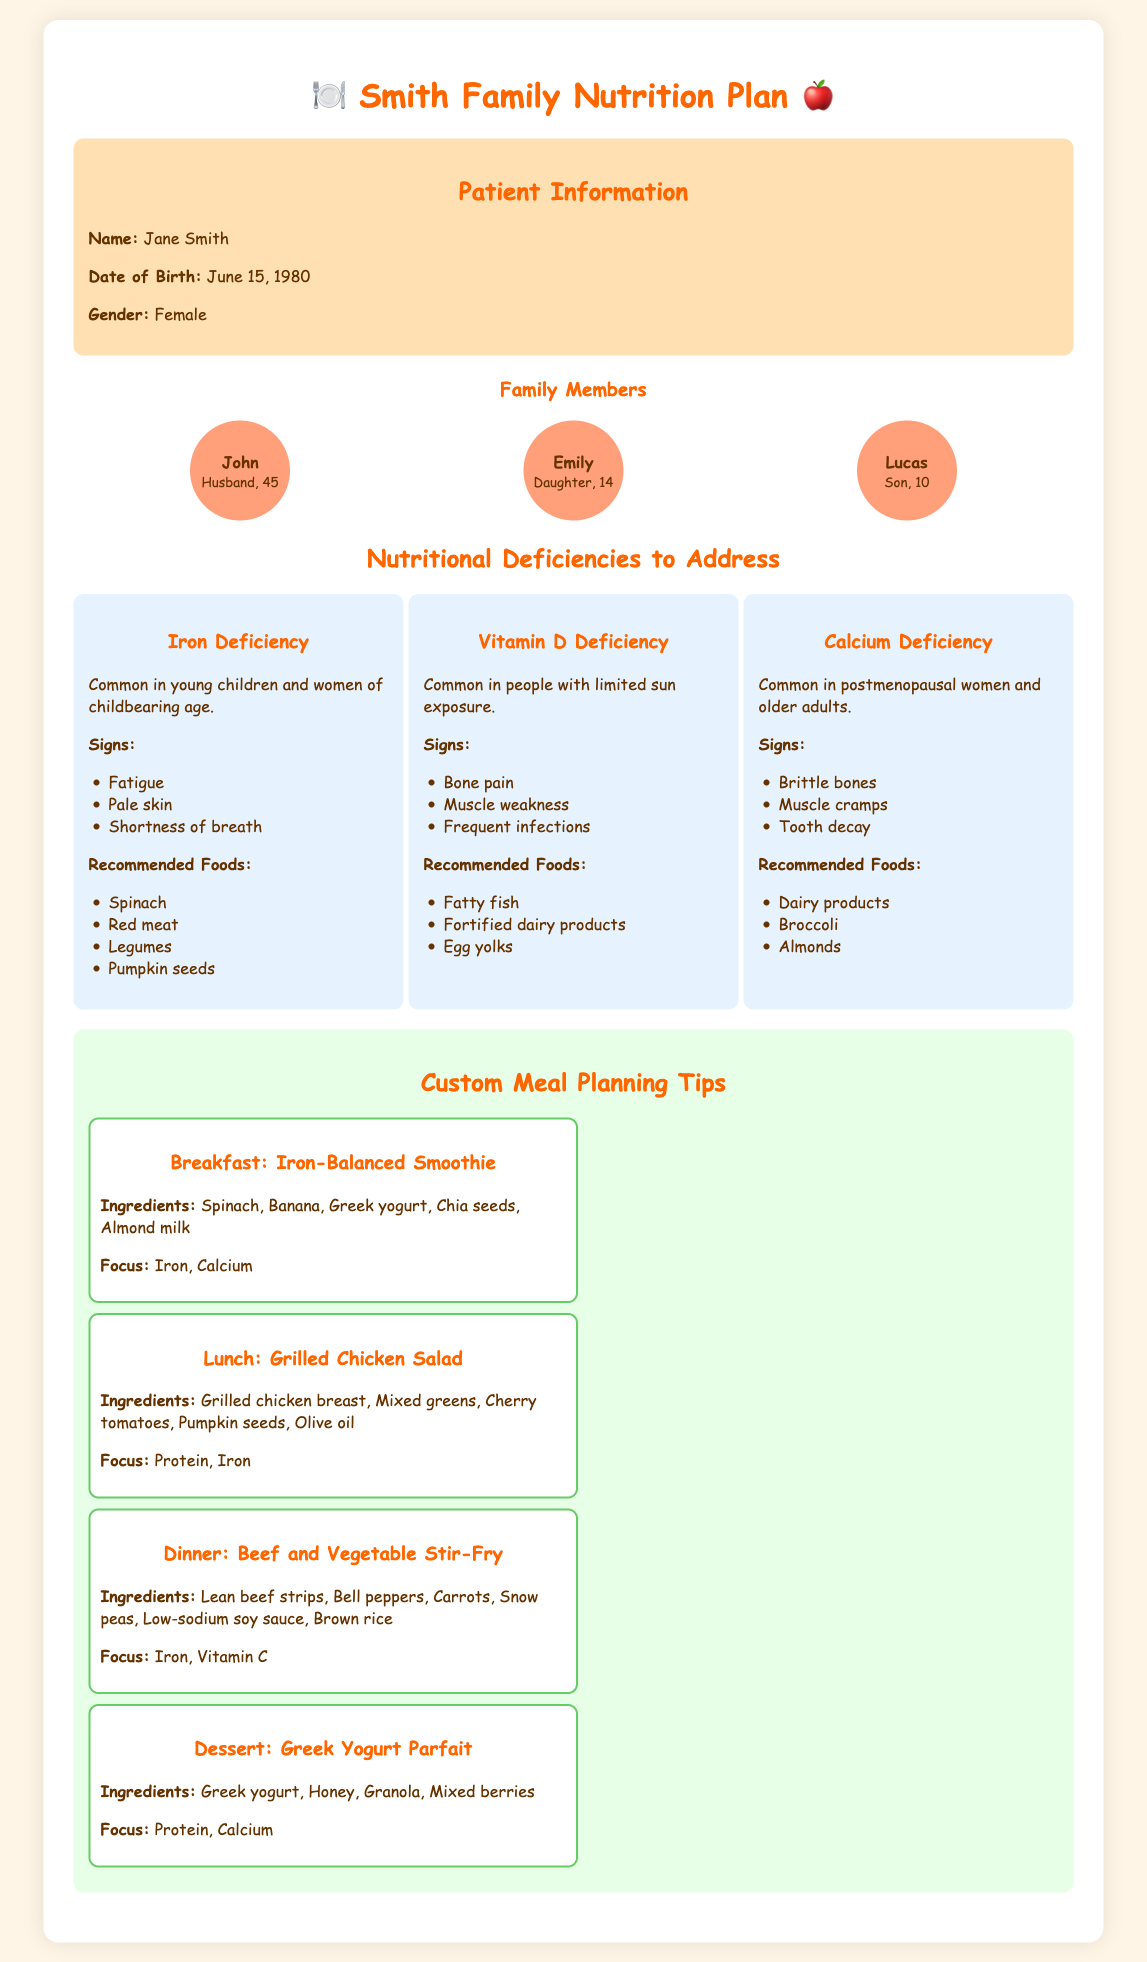What is the name of the patient? The name of the patient is stated in the patient information section of the document.
Answer: Jane Smith How many family members are listed? The document mentions the number of family members in the family members section.
Answer: 3 What is one sign of Iron Deficiency? The document lists signs of Iron Deficiency in a bullet list format.
Answer: Fatigue What is a recommended food for Vitamin D Deficiency? The document provides a list of recommended foods for Vitamin D Deficiency.
Answer: Fatty fish What is the age of Emily? Emily's age is mentioned in the family members section.
Answer: 14 Which meal focuses on Iron and Calcium? The document specifies the focus of each meal and the corresponding meal suggestions.
Answer: Iron-Balanced Smoothie What type of food is suggested for dessert? The meal plan section describes the suggested food for dessert.
Answer: Greek Yogurt Parfait Which deficiency is common in postmenopausal women? The document categorizes each type of deficiency and its common demographics.
Answer: Calcium Deficiency How is the dinner meal prepared? The dinner meal's preparation style and ingredients are outlined in the meal planning tips.
Answer: Stir-Fry 